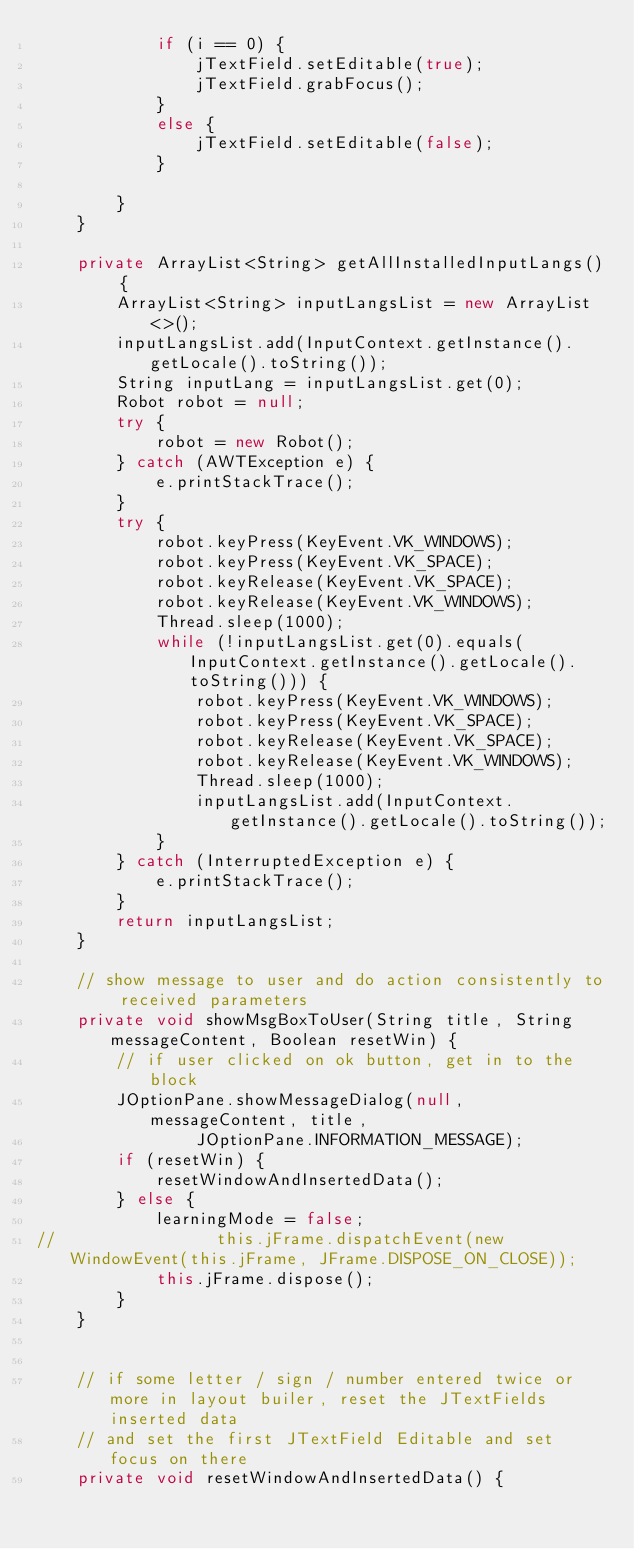Convert code to text. <code><loc_0><loc_0><loc_500><loc_500><_Java_>            if (i == 0) {
                jTextField.setEditable(true);
                jTextField.grabFocus();
            }
            else {
                jTextField.setEditable(false);
            }

        }
    }

    private ArrayList<String> getAllInstalledInputLangs() {
        ArrayList<String> inputLangsList = new ArrayList<>();
        inputLangsList.add(InputContext.getInstance().getLocale().toString());
        String inputLang = inputLangsList.get(0);
        Robot robot = null;
        try {
            robot = new Robot();
        } catch (AWTException e) {
            e.printStackTrace();
        }
        try {
            robot.keyPress(KeyEvent.VK_WINDOWS);
            robot.keyPress(KeyEvent.VK_SPACE);
            robot.keyRelease(KeyEvent.VK_SPACE);
            robot.keyRelease(KeyEvent.VK_WINDOWS);
            Thread.sleep(1000);
            while (!inputLangsList.get(0).equals(InputContext.getInstance().getLocale().toString())) {
                robot.keyPress(KeyEvent.VK_WINDOWS);
                robot.keyPress(KeyEvent.VK_SPACE);
                robot.keyRelease(KeyEvent.VK_SPACE);
                robot.keyRelease(KeyEvent.VK_WINDOWS);
                Thread.sleep(1000);
                inputLangsList.add(InputContext.getInstance().getLocale().toString());
            }
        } catch (InterruptedException e) {
            e.printStackTrace();
        }
        return inputLangsList;
    }

    // show message to user and do action consistently to received parameters
    private void showMsgBoxToUser(String title, String messageContent, Boolean resetWin) {
        // if user clicked on ok button, get in to the block
        JOptionPane.showMessageDialog(null, messageContent, title,
                JOptionPane.INFORMATION_MESSAGE);
        if (resetWin) {
            resetWindowAndInsertedData();
        } else {
            learningMode = false;
//                this.jFrame.dispatchEvent(new WindowEvent(this.jFrame, JFrame.DISPOSE_ON_CLOSE));
            this.jFrame.dispose();
        }
    }


    // if some letter / sign / number entered twice or more in layout builer, reset the JTextFields inserted data
    // and set the first JTextField Editable and set focus on there
    private void resetWindowAndInsertedData() {</code> 